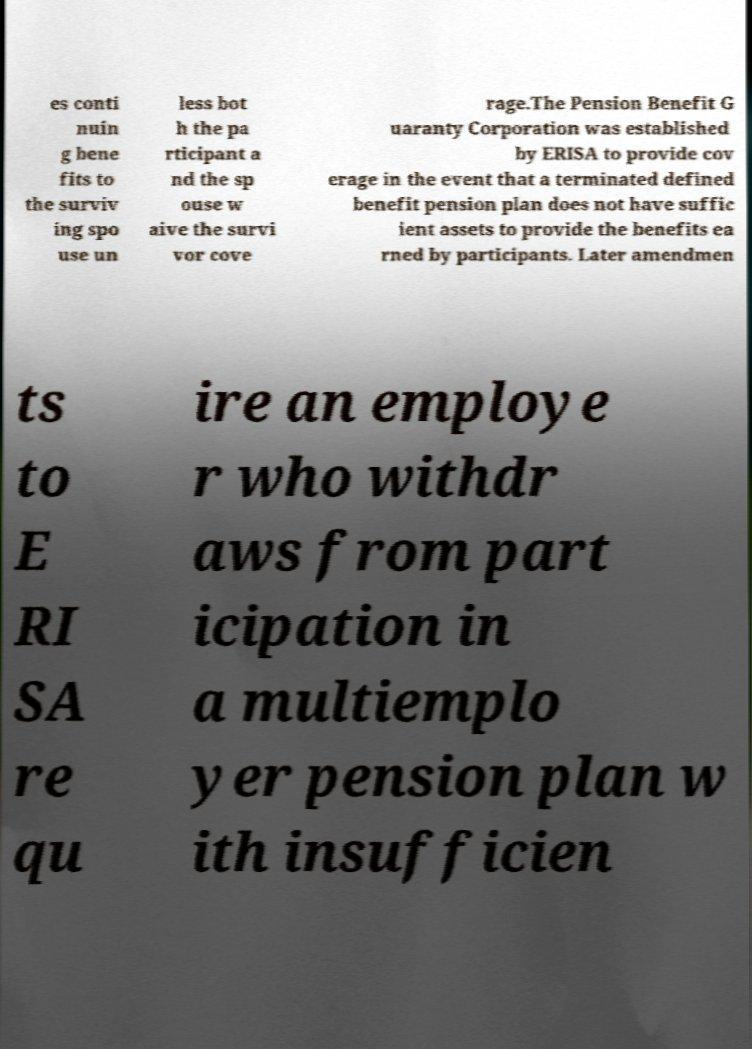Can you accurately transcribe the text from the provided image for me? es conti nuin g bene fits to the surviv ing spo use un less bot h the pa rticipant a nd the sp ouse w aive the survi vor cove rage.The Pension Benefit G uaranty Corporation was established by ERISA to provide cov erage in the event that a terminated defined benefit pension plan does not have suffic ient assets to provide the benefits ea rned by participants. Later amendmen ts to E RI SA re qu ire an employe r who withdr aws from part icipation in a multiemplo yer pension plan w ith insufficien 